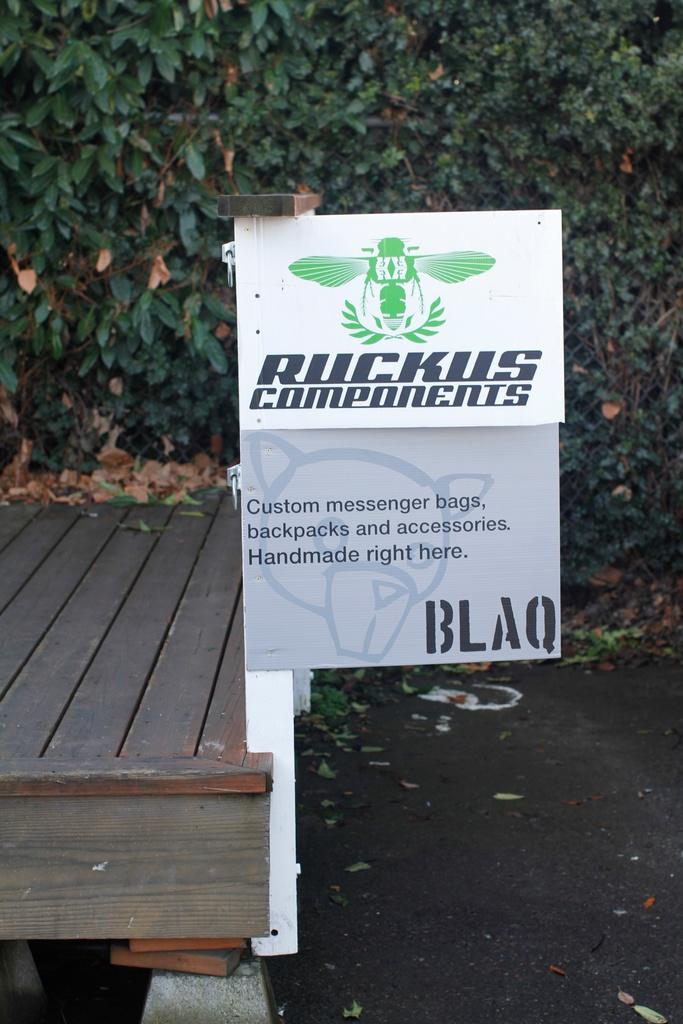What type of material is the plank in the image made of? The wooden plank in the image is made of wood. What is attached to the pole in the image? There are boards with text attached to the pole in the image. Can you describe the text on the boards? Unfortunately, the specific text on the boards cannot be determined from the image. What type of vegetation might be present in the image? There may be trees in the image. What is present on the ground in the image? Dried leaves are present on the ground in the image. Can you hear the voice of the person coughing in the image? There is no person coughing or speaking in the image, as it is a still image and does not contain any audio. What type of dock is visible in the image? There is no dock present in the image. 